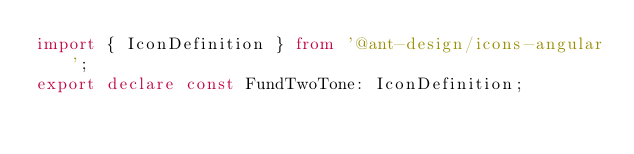<code> <loc_0><loc_0><loc_500><loc_500><_TypeScript_>import { IconDefinition } from '@ant-design/icons-angular';
export declare const FundTwoTone: IconDefinition;
</code> 